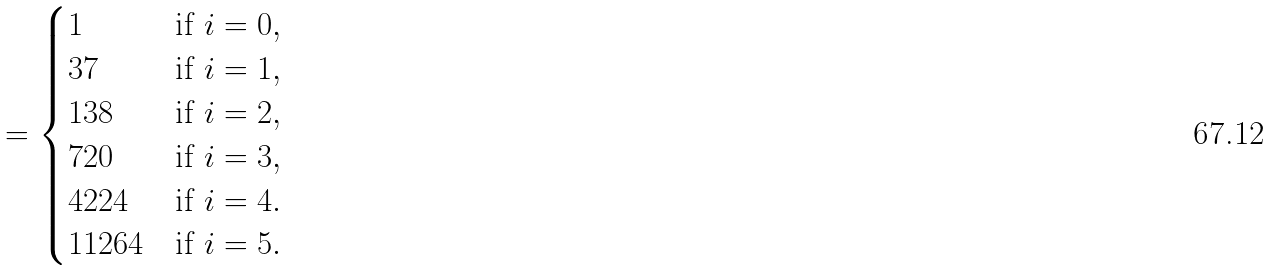<formula> <loc_0><loc_0><loc_500><loc_500>= \begin{cases} 1 & \text {if } i = 0 , \\ 3 7 & \text {if } i = 1 , \\ 1 3 8 & \text {if  } i = 2 , \\ 7 2 0 & \text {if  } i = 3 , \\ 4 2 2 4 & \text {if  } i = 4 . \\ 1 1 2 6 4 & \text {if  } i = 5 . \\ \end{cases}</formula> 